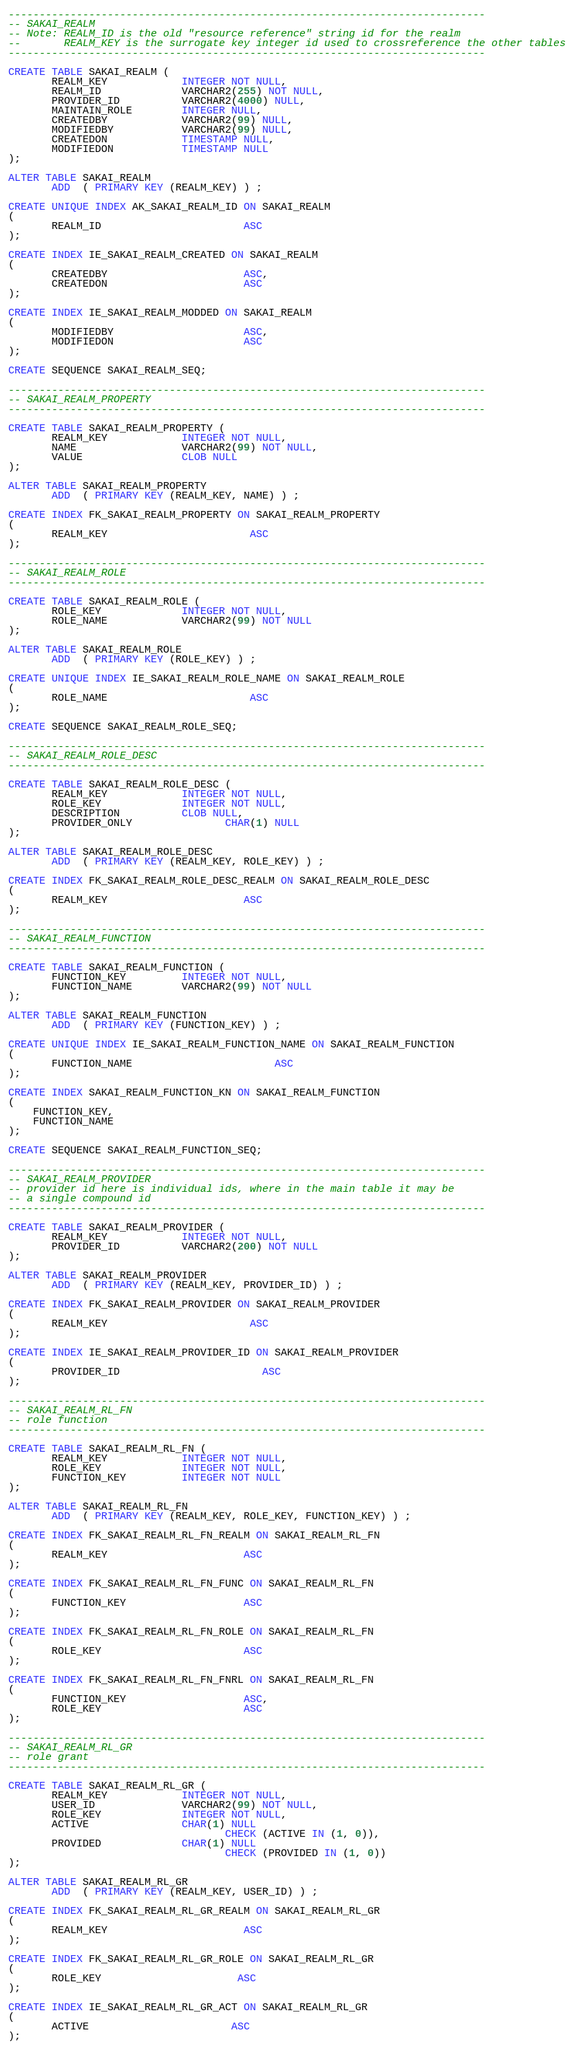<code> <loc_0><loc_0><loc_500><loc_500><_SQL_>-----------------------------------------------------------------------------
-- SAKAI_REALM
-- Note: REALM_ID is the old "resource reference" string id for the realm
--       REALM_KEY is the surrogate key integer id used to crossreference the other tables
-----------------------------------------------------------------------------

CREATE TABLE SAKAI_REALM (
       REALM_KEY            INTEGER NOT NULL,
       REALM_ID             VARCHAR2(255) NOT NULL,
       PROVIDER_ID          VARCHAR2(4000) NULL,
       MAINTAIN_ROLE        INTEGER NULL,
       CREATEDBY            VARCHAR2(99) NULL,
       MODIFIEDBY           VARCHAR2(99) NULL,
       CREATEDON            TIMESTAMP NULL,
       MODIFIEDON           TIMESTAMP NULL
);

ALTER TABLE SAKAI_REALM
       ADD  ( PRIMARY KEY (REALM_KEY) ) ;

CREATE UNIQUE INDEX AK_SAKAI_REALM_ID ON SAKAI_REALM
(
       REALM_ID                       ASC
);

CREATE INDEX IE_SAKAI_REALM_CREATED ON SAKAI_REALM
(
       CREATEDBY                      ASC,
       CREATEDON                      ASC
);

CREATE INDEX IE_SAKAI_REALM_MODDED ON SAKAI_REALM
(
       MODIFIEDBY                     ASC,
       MODIFIEDON                     ASC
);

CREATE SEQUENCE SAKAI_REALM_SEQ;

-----------------------------------------------------------------------------
-- SAKAI_REALM_PROPERTY
-----------------------------------------------------------------------------

CREATE TABLE SAKAI_REALM_PROPERTY (
       REALM_KEY            INTEGER NOT NULL,
       NAME                 VARCHAR2(99) NOT NULL,
       VALUE                CLOB NULL
);

ALTER TABLE SAKAI_REALM_PROPERTY
       ADD  ( PRIMARY KEY (REALM_KEY, NAME) ) ;

CREATE INDEX FK_SAKAI_REALM_PROPERTY ON SAKAI_REALM_PROPERTY
(
       REALM_KEY                       ASC
);

-----------------------------------------------------------------------------
-- SAKAI_REALM_ROLE
-----------------------------------------------------------------------------

CREATE TABLE SAKAI_REALM_ROLE (
       ROLE_KEY             INTEGER NOT NULL,
       ROLE_NAME            VARCHAR2(99) NOT NULL
);

ALTER TABLE SAKAI_REALM_ROLE
       ADD  ( PRIMARY KEY (ROLE_KEY) ) ;

CREATE UNIQUE INDEX IE_SAKAI_REALM_ROLE_NAME ON SAKAI_REALM_ROLE
(
       ROLE_NAME                       ASC
);

CREATE SEQUENCE SAKAI_REALM_ROLE_SEQ;

-----------------------------------------------------------------------------
-- SAKAI_REALM_ROLE_DESC
-----------------------------------------------------------------------------

CREATE TABLE SAKAI_REALM_ROLE_DESC (
       REALM_KEY            INTEGER NOT NULL,
       ROLE_KEY             INTEGER NOT NULL,
       DESCRIPTION          CLOB NULL,
       PROVIDER_ONLY               CHAR(1) NULL
);

ALTER TABLE SAKAI_REALM_ROLE_DESC
       ADD  ( PRIMARY KEY (REALM_KEY, ROLE_KEY) ) ;

CREATE INDEX FK_SAKAI_REALM_ROLE_DESC_REALM ON SAKAI_REALM_ROLE_DESC
(
       REALM_KEY                      ASC
);

-----------------------------------------------------------------------------
-- SAKAI_REALM_FUNCTION
-----------------------------------------------------------------------------

CREATE TABLE SAKAI_REALM_FUNCTION (
       FUNCTION_KEY         INTEGER NOT NULL,
       FUNCTION_NAME        VARCHAR2(99) NOT NULL
);

ALTER TABLE SAKAI_REALM_FUNCTION
       ADD  ( PRIMARY KEY (FUNCTION_KEY) ) ;

CREATE UNIQUE INDEX IE_SAKAI_REALM_FUNCTION_NAME ON SAKAI_REALM_FUNCTION
(
       FUNCTION_NAME                       ASC
);

CREATE INDEX SAKAI_REALM_FUNCTION_KN ON SAKAI_REALM_FUNCTION
(
	FUNCTION_KEY,
	FUNCTION_NAME
);

CREATE SEQUENCE SAKAI_REALM_FUNCTION_SEQ;

-----------------------------------------------------------------------------
-- SAKAI_REALM_PROVIDER
-- provider id here is individual ids, where in the main table it may be
-- a single compound id
-----------------------------------------------------------------------------

CREATE TABLE SAKAI_REALM_PROVIDER (
       REALM_KEY            INTEGER NOT NULL,
       PROVIDER_ID          VARCHAR2(200) NOT NULL
);

ALTER TABLE SAKAI_REALM_PROVIDER
       ADD  ( PRIMARY KEY (REALM_KEY, PROVIDER_ID) ) ;

CREATE INDEX FK_SAKAI_REALM_PROVIDER ON SAKAI_REALM_PROVIDER
(
       REALM_KEY                       ASC
);

CREATE INDEX IE_SAKAI_REALM_PROVIDER_ID ON SAKAI_REALM_PROVIDER
(
       PROVIDER_ID                       ASC
);

-----------------------------------------------------------------------------
-- SAKAI_REALM_RL_FN
-- role function
-----------------------------------------------------------------------------

CREATE TABLE SAKAI_REALM_RL_FN (
       REALM_KEY            INTEGER NOT NULL,
       ROLE_KEY             INTEGER NOT NULL,
       FUNCTION_KEY         INTEGER NOT NULL
);

ALTER TABLE SAKAI_REALM_RL_FN
       ADD  ( PRIMARY KEY (REALM_KEY, ROLE_KEY, FUNCTION_KEY) ) ;

CREATE INDEX FK_SAKAI_REALM_RL_FN_REALM ON SAKAI_REALM_RL_FN
(
       REALM_KEY                      ASC
);

CREATE INDEX FK_SAKAI_REALM_RL_FN_FUNC ON SAKAI_REALM_RL_FN
(
       FUNCTION_KEY                   ASC
);

CREATE INDEX FK_SAKAI_REALM_RL_FN_ROLE ON SAKAI_REALM_RL_FN
(
       ROLE_KEY                       ASC
);

CREATE INDEX FK_SAKAI_REALM_RL_FN_FNRL ON SAKAI_REALM_RL_FN
(
       FUNCTION_KEY                   ASC,
       ROLE_KEY                       ASC
);

-----------------------------------------------------------------------------
-- SAKAI_REALM_RL_GR
-- role grant
-----------------------------------------------------------------------------

CREATE TABLE SAKAI_REALM_RL_GR (
       REALM_KEY            INTEGER NOT NULL,
       USER_ID              VARCHAR2(99) NOT NULL,
       ROLE_KEY             INTEGER NOT NULL,
       ACTIVE               CHAR(1) NULL
                                   CHECK (ACTIVE IN (1, 0)),
       PROVIDED             CHAR(1) NULL
                                   CHECK (PROVIDED IN (1, 0))
);

ALTER TABLE SAKAI_REALM_RL_GR
       ADD  ( PRIMARY KEY (REALM_KEY, USER_ID) ) ;

CREATE INDEX FK_SAKAI_REALM_RL_GR_REALM ON SAKAI_REALM_RL_GR
(
       REALM_KEY                      ASC
);

CREATE INDEX FK_SAKAI_REALM_RL_GR_ROLE ON SAKAI_REALM_RL_GR
(
       ROLE_KEY                      ASC
);

CREATE INDEX IE_SAKAI_REALM_RL_GR_ACT ON SAKAI_REALM_RL_GR
(
       ACTIVE                       ASC
);
</code> 